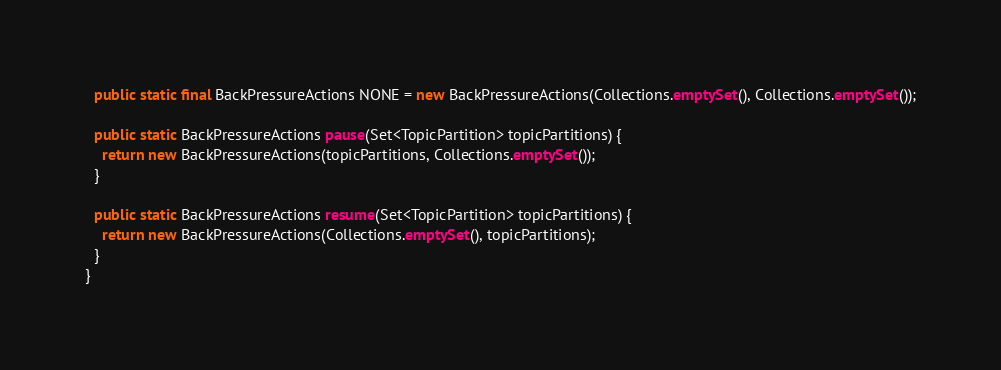<code> <loc_0><loc_0><loc_500><loc_500><_Java_>  public static final BackPressureActions NONE = new BackPressureActions(Collections.emptySet(), Collections.emptySet());

  public static BackPressureActions pause(Set<TopicPartition> topicPartitions) {
    return new BackPressureActions(topicPartitions, Collections.emptySet());
  }

  public static BackPressureActions resume(Set<TopicPartition> topicPartitions) {
    return new BackPressureActions(Collections.emptySet(), topicPartitions);
  }
}
</code> 